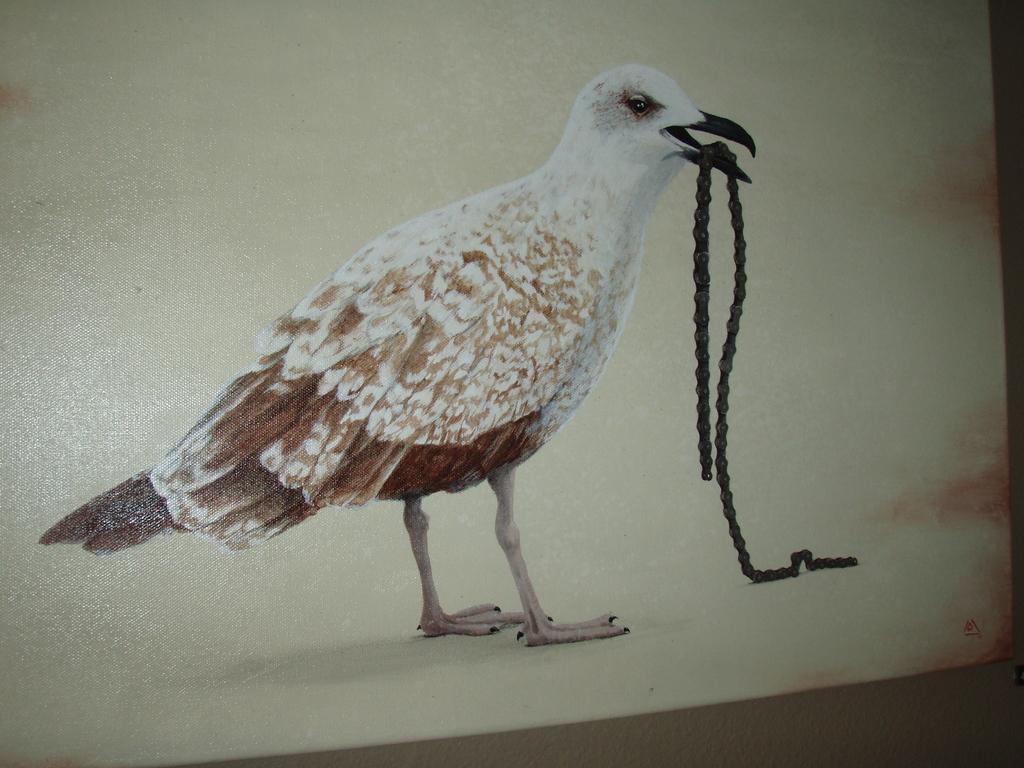What is present in the image? There is a poster in the image. What can be seen on the poster? The poster contains an image of a bird. What type of face can be seen on the bird in the image? There is no face visible on the bird in the image, as it is a poster with an image of a bird and not a photograph of a real bird. 